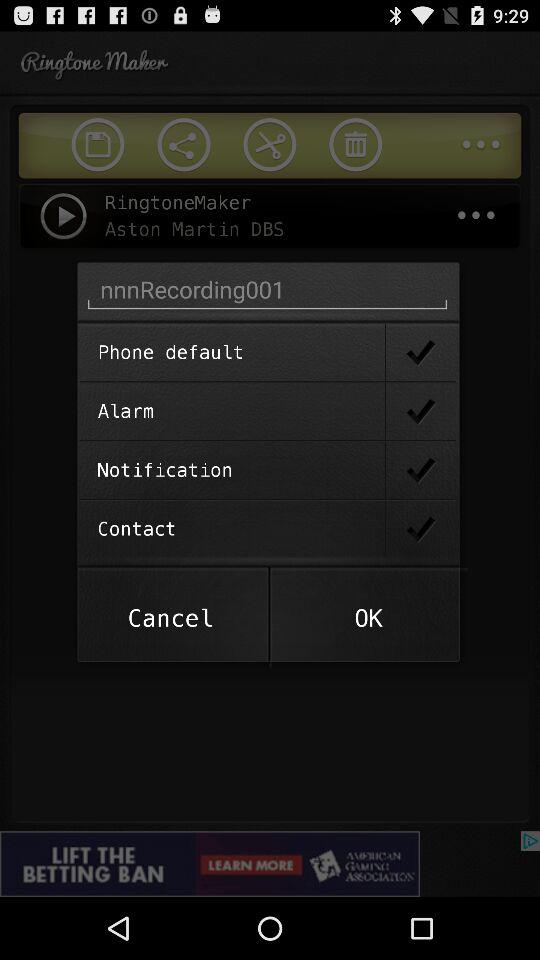What is the name of the recording? The name of the recording is "nnnRecording001". 